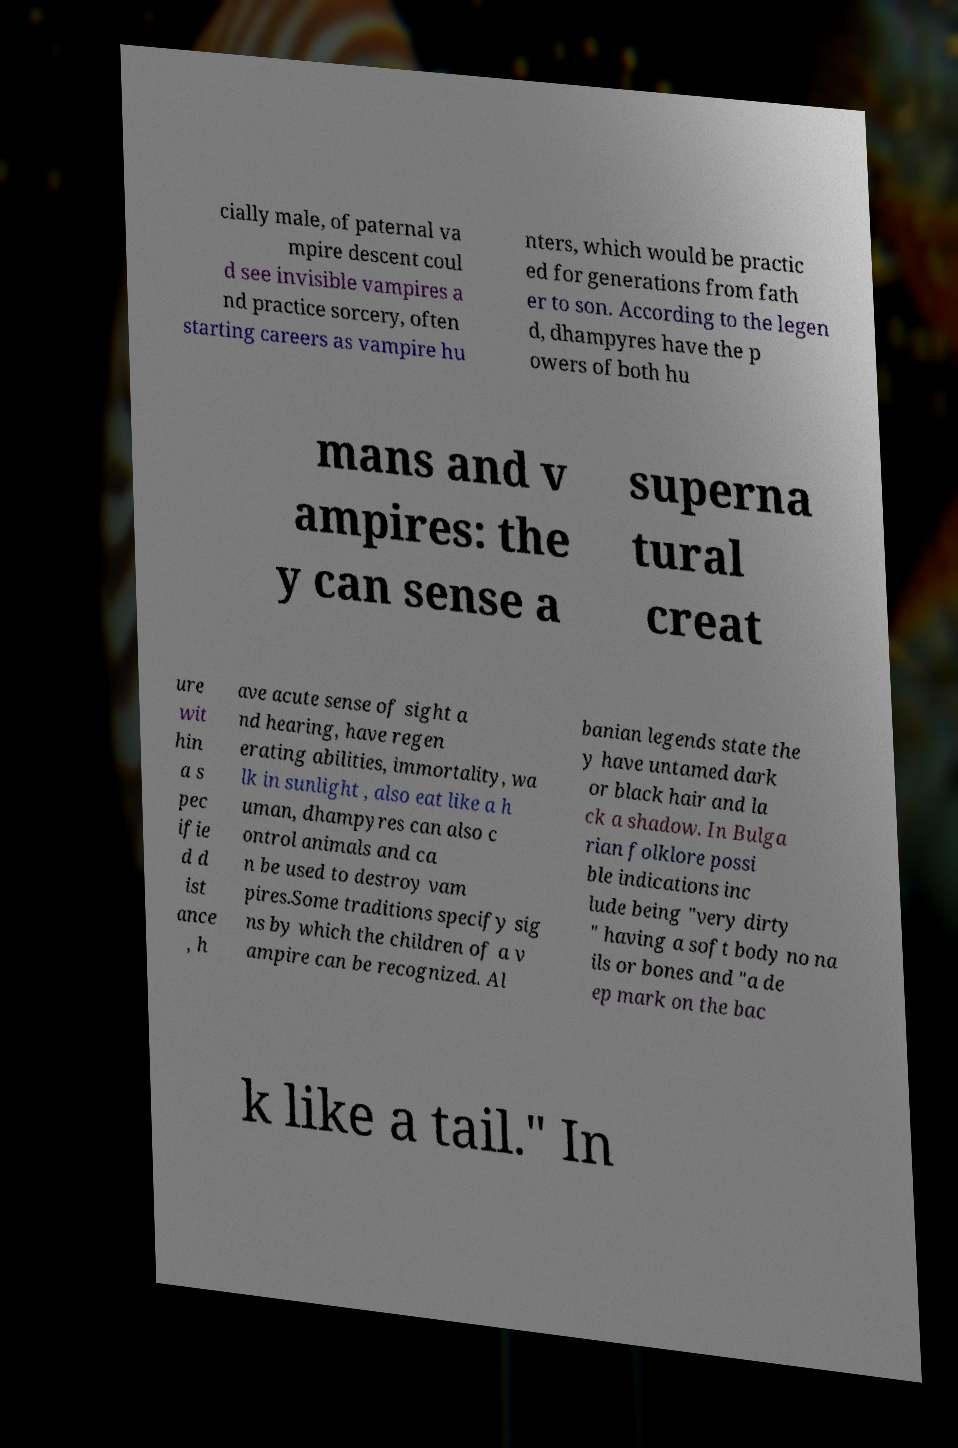Please identify and transcribe the text found in this image. cially male, of paternal va mpire descent coul d see invisible vampires a nd practice sorcery, often starting careers as vampire hu nters, which would be practic ed for generations from fath er to son. According to the legen d, dhampyres have the p owers of both hu mans and v ampires: the y can sense a superna tural creat ure wit hin a s pec ifie d d ist ance , h ave acute sense of sight a nd hearing, have regen erating abilities, immortality, wa lk in sunlight , also eat like a h uman, dhampyres can also c ontrol animals and ca n be used to destroy vam pires.Some traditions specify sig ns by which the children of a v ampire can be recognized. Al banian legends state the y have untamed dark or black hair and la ck a shadow. In Bulga rian folklore possi ble indications inc lude being "very dirty " having a soft body no na ils or bones and "a de ep mark on the bac k like a tail." In 